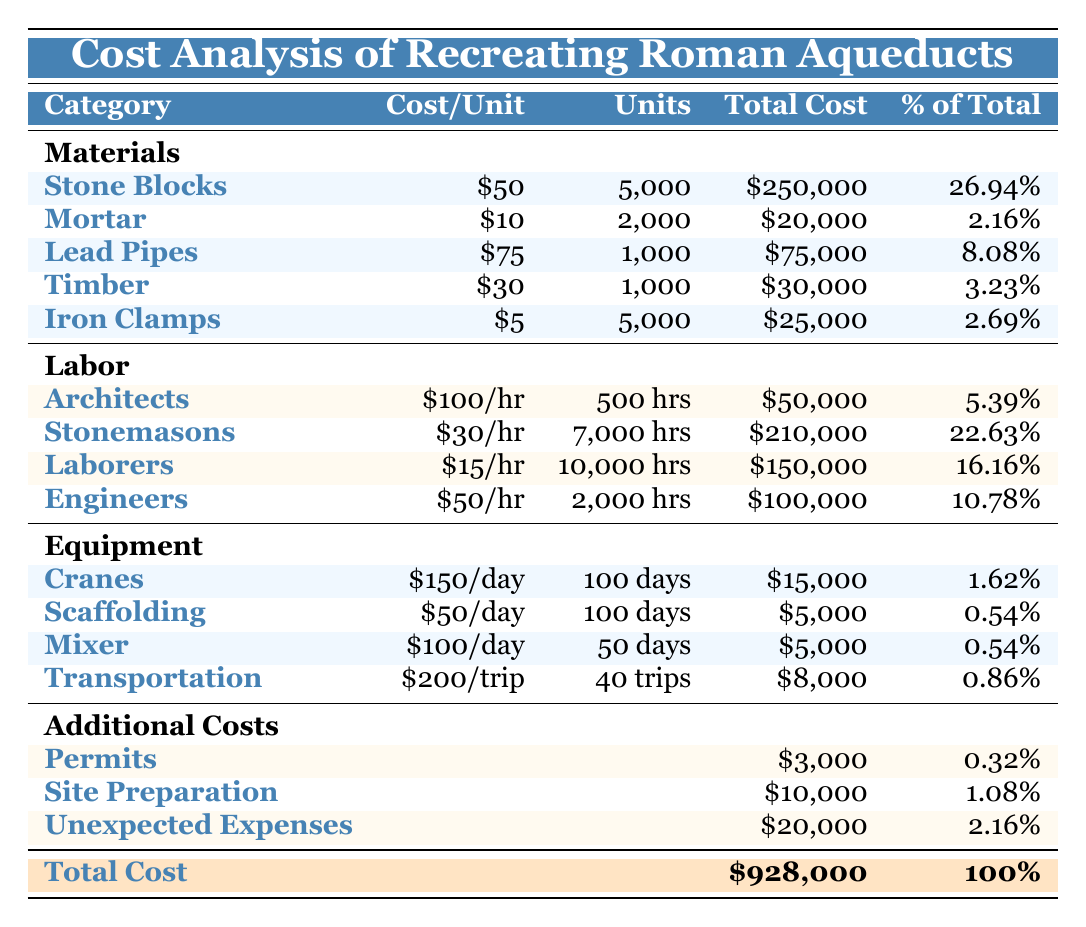What is the total cost of materials? To find the total cost of materials, we need to sum the total costs listed under the materials section: 250,000 + 20,000 + 75,000 + 30,000 + 25,000 = 400,000.
Answer: 400,000 What percentage of the total cost does labor represent? The total cost of labor is calculated by summing the total costs for each role: 50,000 + 210,000 + 150,000 + 100,000 = 510,000. To find the percentage, divide the total labor cost by the overall total cost: (510,000 / 928,000) * 100 = 55.0%.
Answer: 55.0% Is the cost of lead pipes higher than the combined cost of timber and iron clamps? The total cost of lead pipes is 75,000. The combined cost of timber and iron clamps is 30,000 + 25,000 = 55,000. Since 75,000 is greater than 55,000, the statement is true.
Answer: Yes How much more does stonemasonry labor cost compared to the cost of stone blocks? The total cost of stonemasonry labor is 210,000, and the total cost of stone blocks is 250,000. To find the difference: 250,000 - 210,000 = 40,000.
Answer: 40,000 What is the total cost incurred for permits and site preparation? To calculate the total cost for permits and site preparation, we add the two costs: 3,000 (permits) + 10,000 (site preparation) = 13,000.
Answer: 13,000 What is the average cost per unit of labor? The total cost of labor is 510,000, and there are four roles (architects, stonemasons, laborers, engineers), which gives an average of: 510,000 / 4 = 127,500. However, interpreting labor unit cost can be tricky since it's expressed hourly. To find a reasonable average: (100 + 30 + 15 + 50) / 4 = 48.75.
Answer: 48.75 How much do cranes and scaffolding together cost? The cost of cranes is 15,000 and the cost of scaffolding is 5,000. Adding these gives: 15,000 + 5,000 = 20,000.
Answer: 20,000 What proportion does unexpected expenses make up of the total cost? The total cost for unexpected expenses is 20,000. To find the proportion, we divide by the total cost: (20,000 / 928,000) * 100 = 2.16%.
Answer: 2.16% 